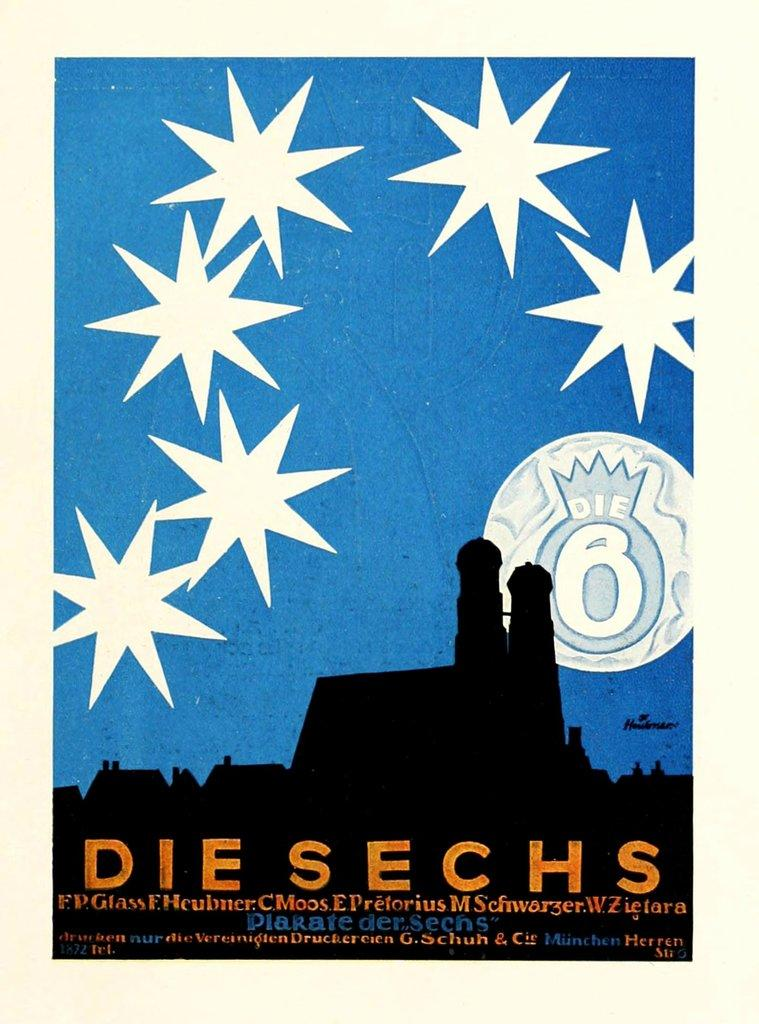<image>
Render a clear and concise summary of the photo. A poster that says Die Sechs on the bottom of it. 